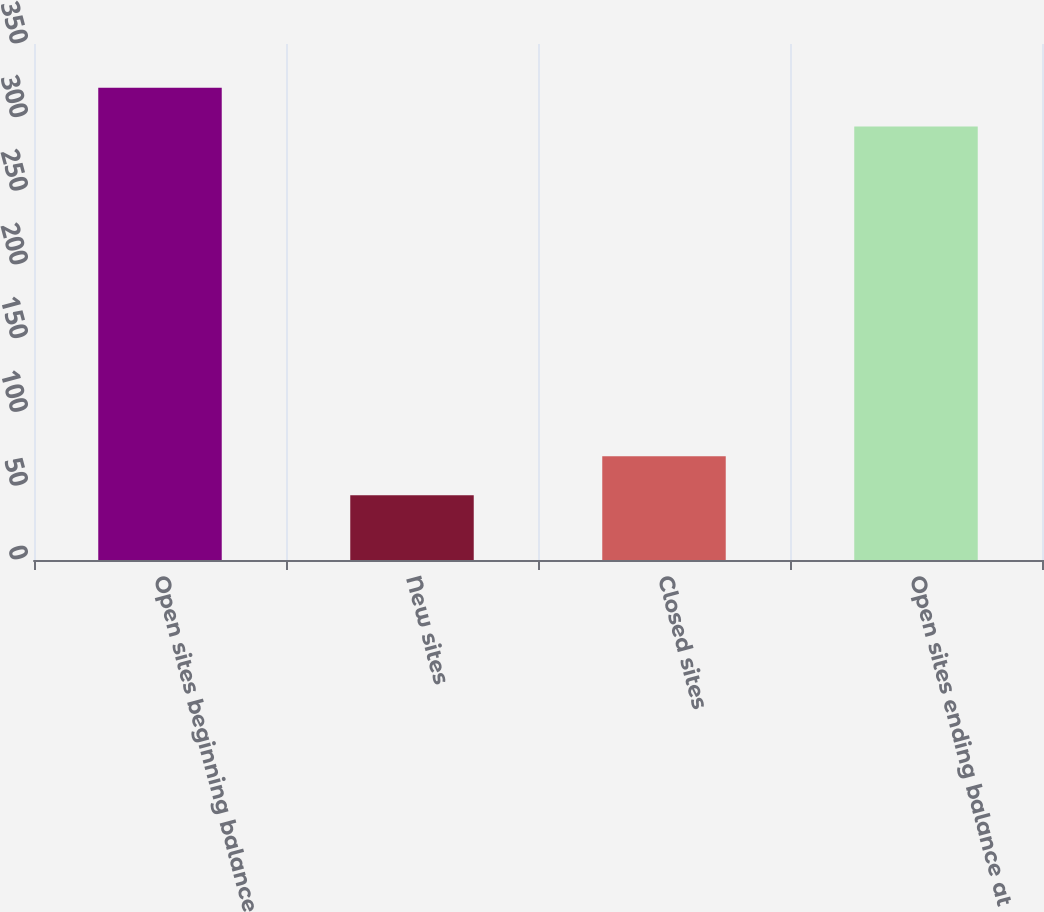Convert chart. <chart><loc_0><loc_0><loc_500><loc_500><bar_chart><fcel>Open sites beginning balance<fcel>New sites<fcel>Closed sites<fcel>Open sites ending balance at<nl><fcel>320.3<fcel>44<fcel>70.3<fcel>294<nl></chart> 